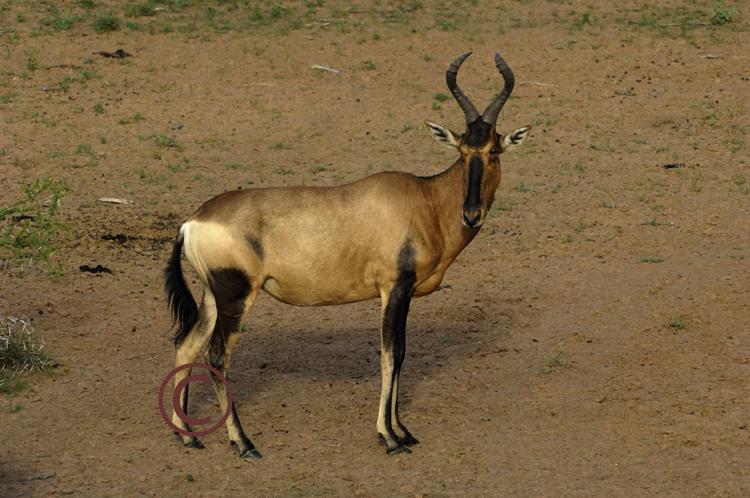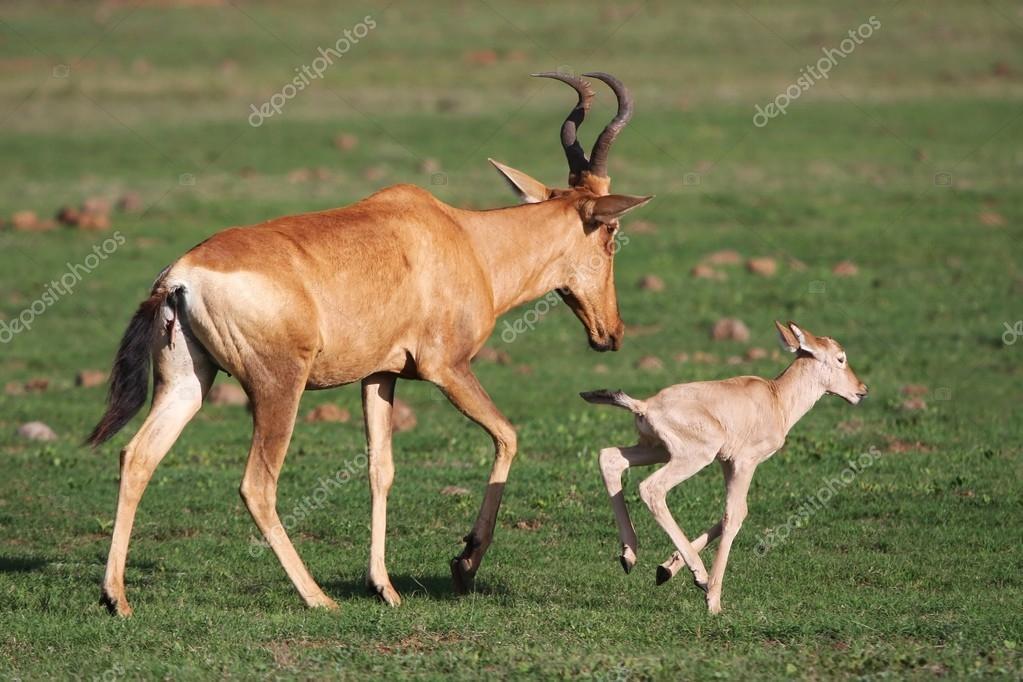The first image is the image on the left, the second image is the image on the right. For the images shown, is this caption "One of the images shows a mommy and a baby animal together, but not touching." true? Answer yes or no. Yes. The first image is the image on the left, the second image is the image on the right. For the images displayed, is the sentence "Exactly two animals are standing." factually correct? Answer yes or no. No. 